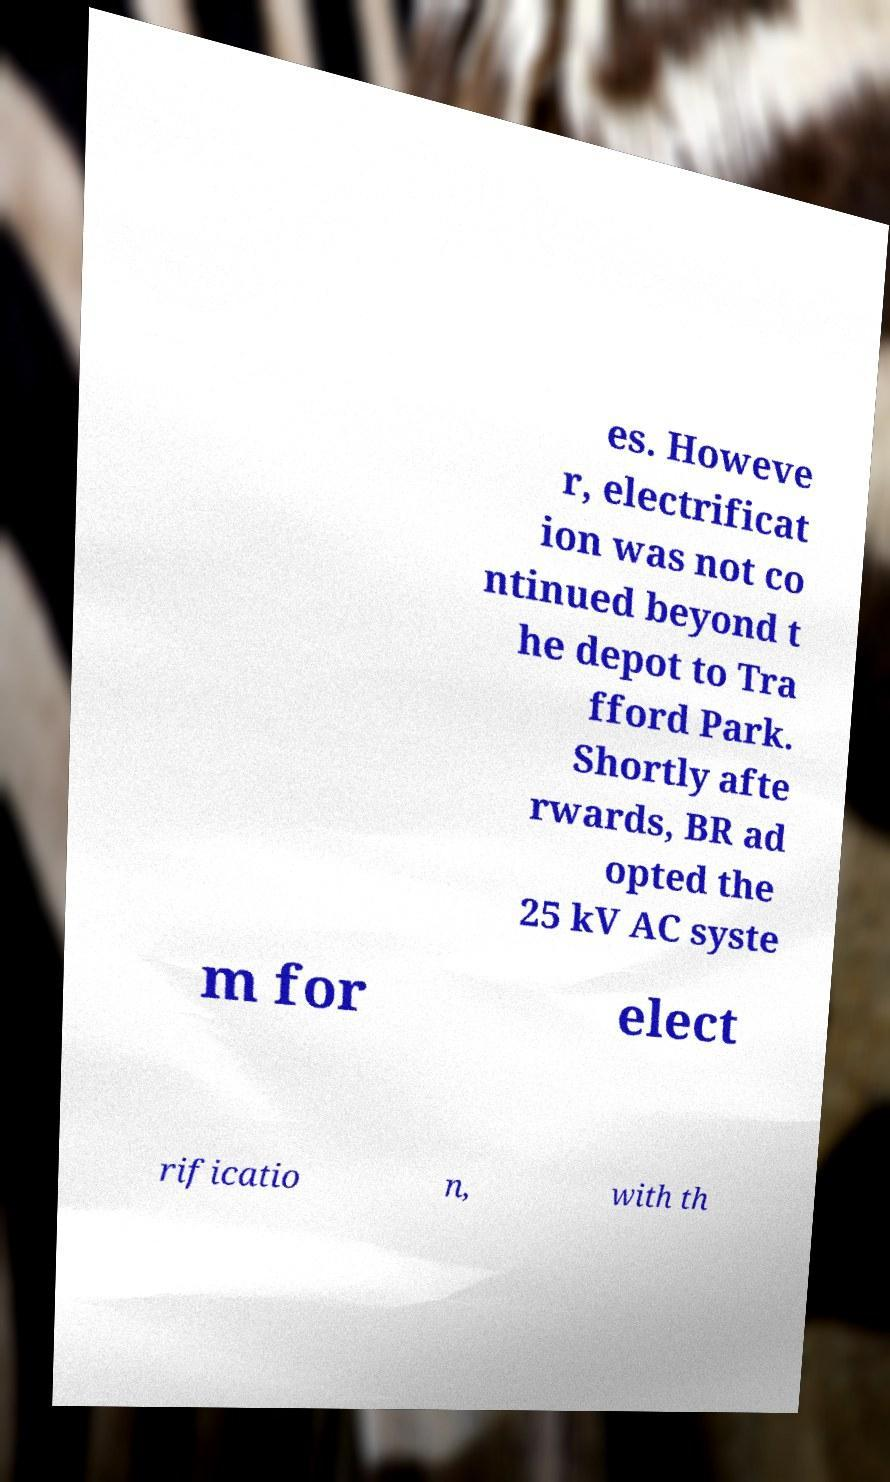Can you read and provide the text displayed in the image?This photo seems to have some interesting text. Can you extract and type it out for me? es. Howeve r, electrificat ion was not co ntinued beyond t he depot to Tra fford Park. Shortly afte rwards, BR ad opted the 25 kV AC syste m for elect rificatio n, with th 